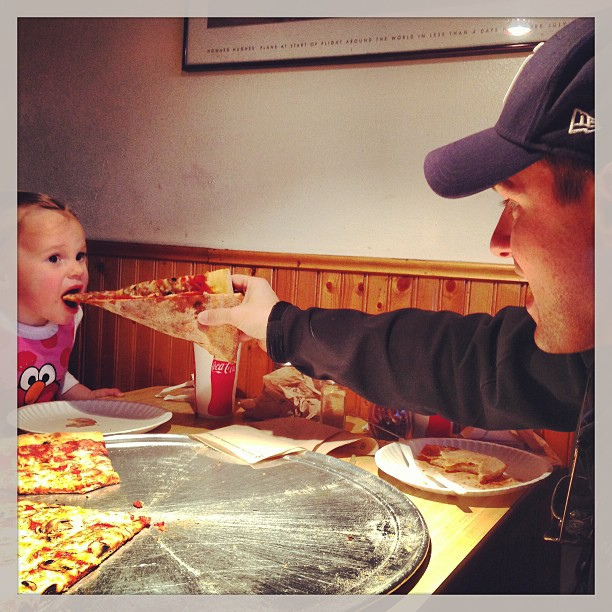Please transcribe the text in this image. n 